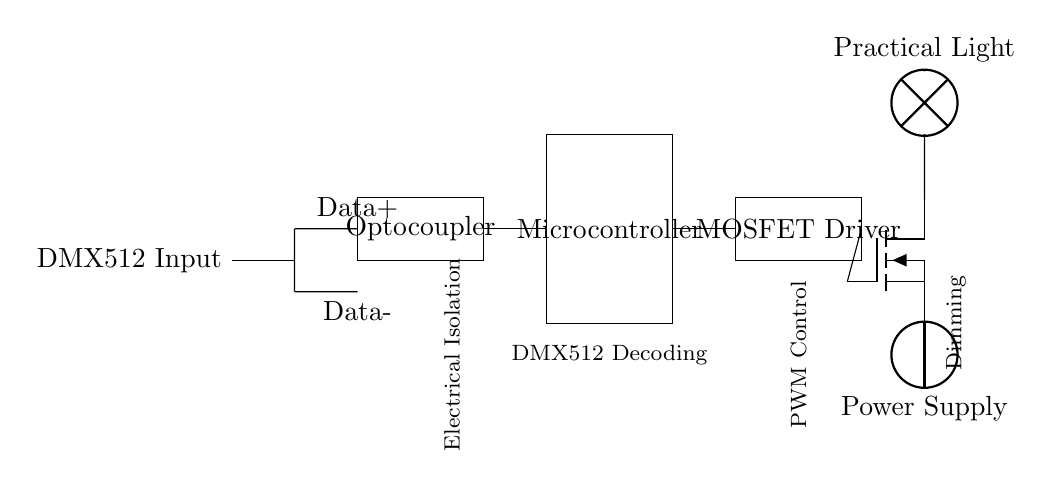What are the two data lines in the circuit? The two data lines are labeled Data+ and Data-. They are used to transmit the DMX512 signal.
Answer: Data+ and Data- What component provides electrical isolation? The Optocoupler is used for electrical isolation in the circuit to separate the DMX512 input from the rest of the circuitry.
Answer: Optocoupler What is the role of the Microcontroller? The Microcontroller is responsible for DMX512 decoding, interpreting the DMX signal to send control commands to the following components.
Answer: DMX512 Decoding What type of control does the MOSFET Driver provide? The MOSFET Driver provides PWM control, allowing for precise dimming of the practical light by rapidly switching the MOSFET on and off.
Answer: PWM Control How is the practical light connected in the circuit? The practical light is connected to the drain of the MOSFET, which controls its brightness through the switching mechanism of the MOSFET.
Answer: To the drain of the MOSFET What is the function of the MOSFET in this circuit? The MOSFET acts as a switch that regulates the power to the practical light based on the control signals it receives from the MOSFET Driver.
Answer: Regulates power 